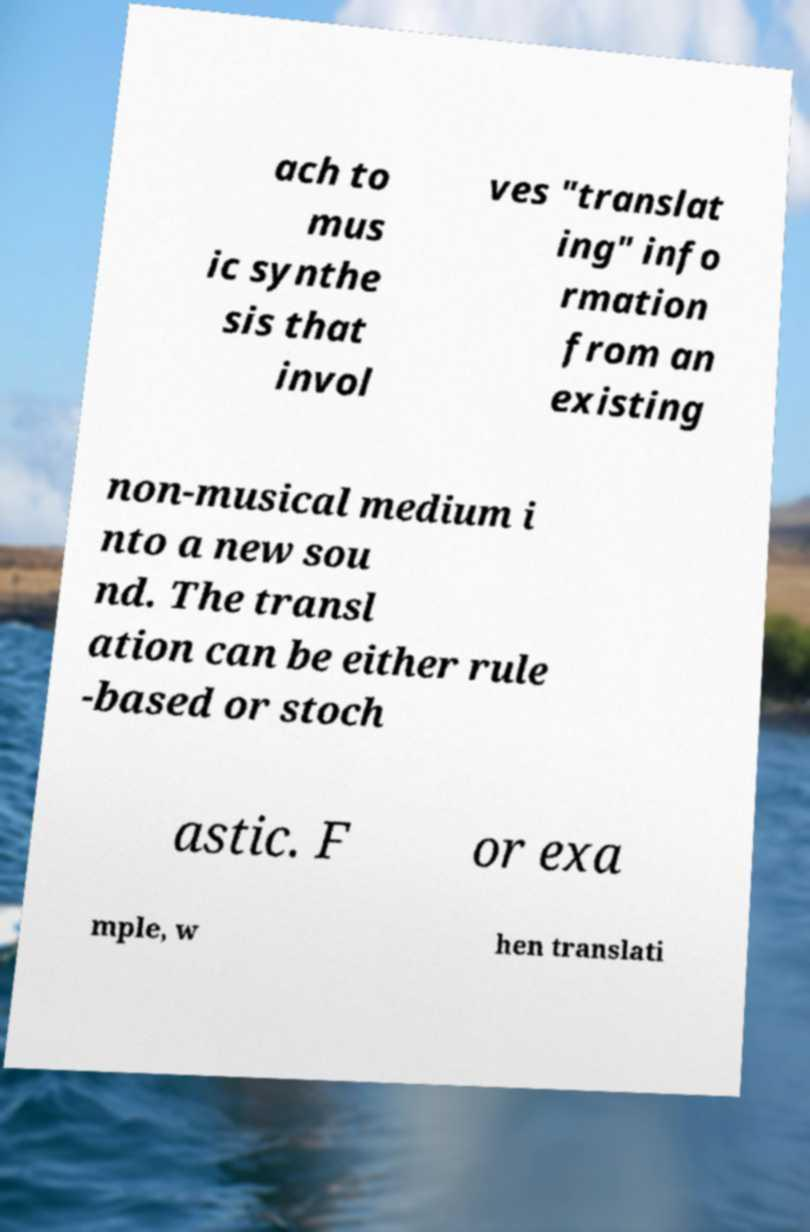What messages or text are displayed in this image? I need them in a readable, typed format. ach to mus ic synthe sis that invol ves "translat ing" info rmation from an existing non-musical medium i nto a new sou nd. The transl ation can be either rule -based or stoch astic. F or exa mple, w hen translati 